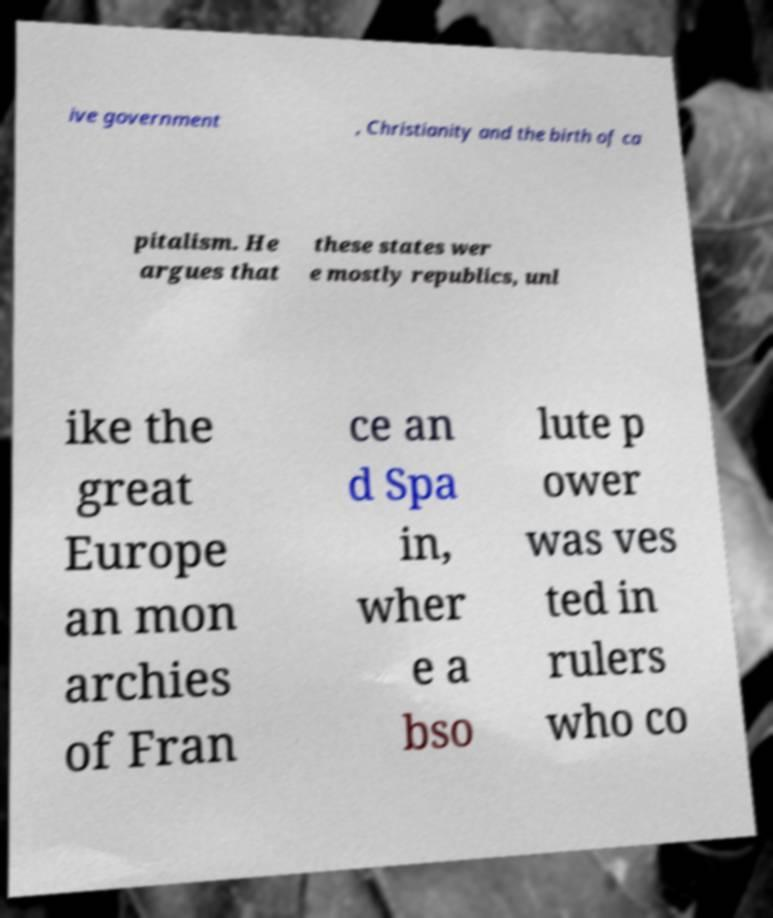Can you accurately transcribe the text from the provided image for me? ive government , Christianity and the birth of ca pitalism. He argues that these states wer e mostly republics, unl ike the great Europe an mon archies of Fran ce an d Spa in, wher e a bso lute p ower was ves ted in rulers who co 